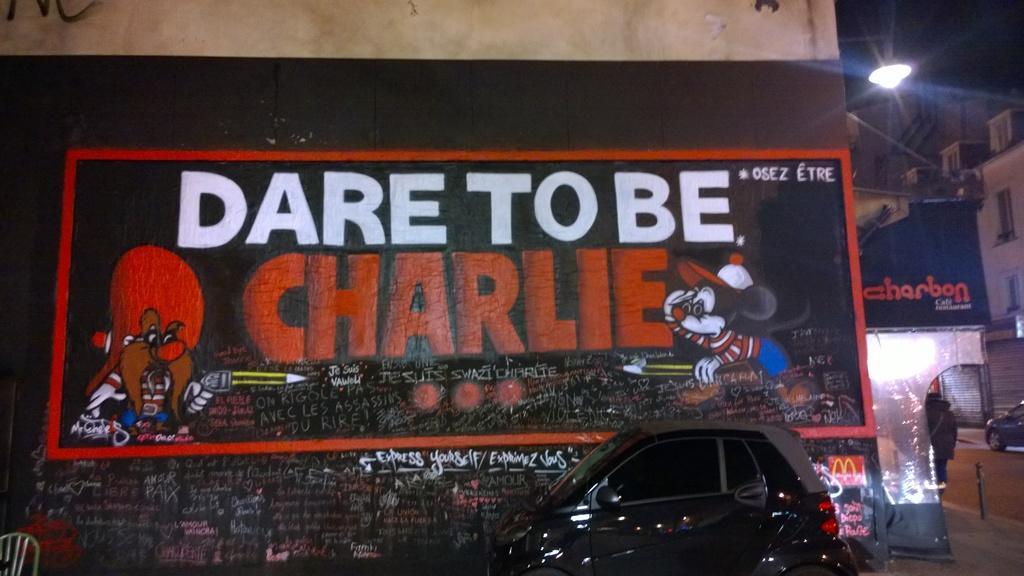Could you give a brief overview of what you see in this image? This picture shows the spray painting wall on which we can see "Dare to be charlie'' is written. In the front we can see small black color car. Beside we can see post light and white color building. 